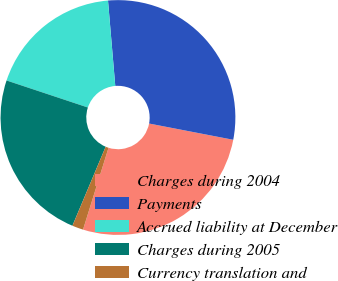<chart> <loc_0><loc_0><loc_500><loc_500><pie_chart><fcel>Charges during 2004<fcel>Payments<fcel>Accrued liability at December<fcel>Charges during 2005<fcel>Currency translation and<nl><fcel>26.77%<fcel>29.39%<fcel>18.54%<fcel>23.77%<fcel>1.53%<nl></chart> 